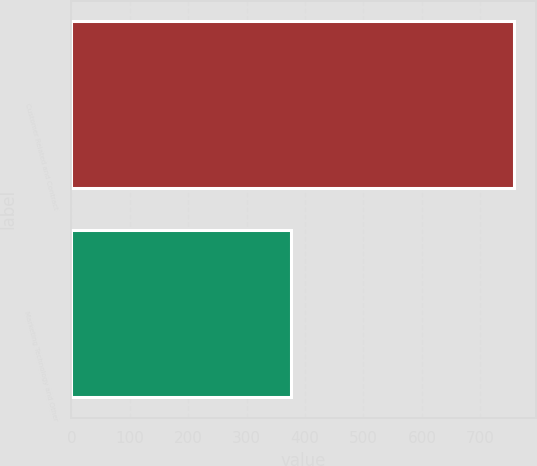Convert chart. <chart><loc_0><loc_0><loc_500><loc_500><bar_chart><fcel>Customer Related and Contract<fcel>Marketing Technology and Other<nl><fcel>757<fcel>376<nl></chart> 